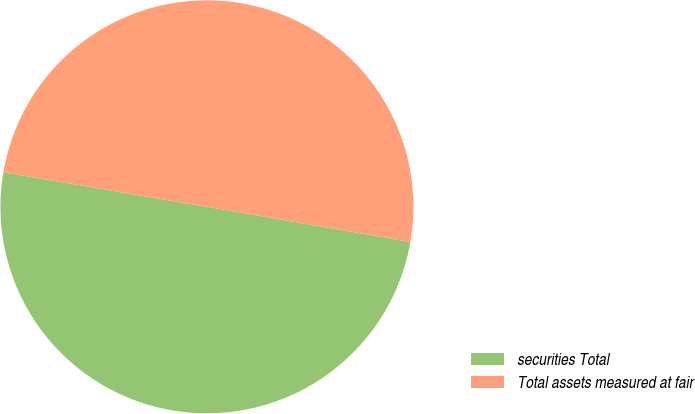Convert chart to OTSL. <chart><loc_0><loc_0><loc_500><loc_500><pie_chart><fcel>securities Total<fcel>Total assets measured at fair<nl><fcel>49.95%<fcel>50.05%<nl></chart> 